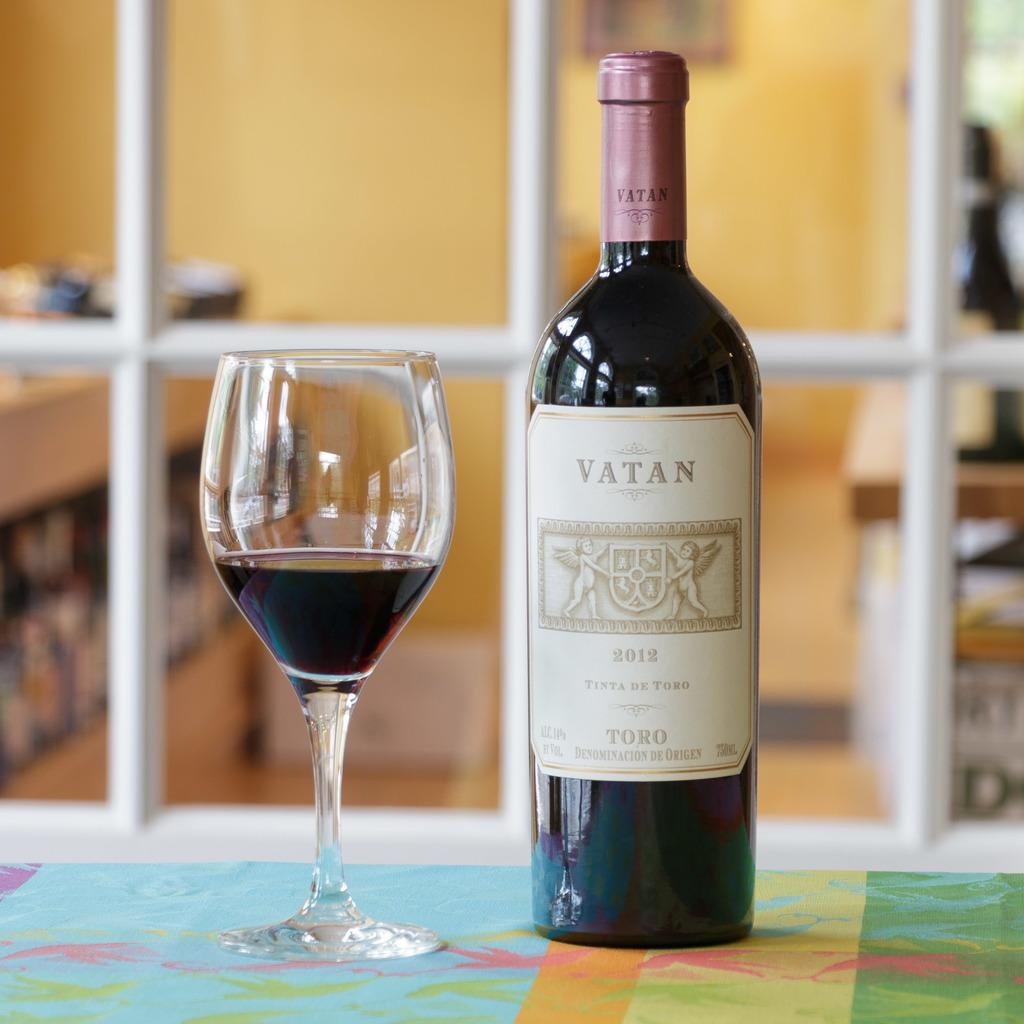<image>
Share a concise interpretation of the image provided. a bottle that has the word Vatan on the front 